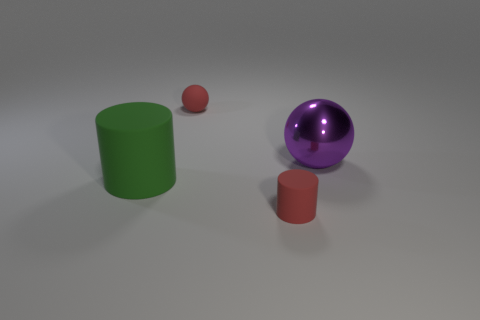Add 1 cyan metallic blocks. How many objects exist? 5 Subtract 1 cylinders. How many cylinders are left? 1 Subtract all brown balls. Subtract all gray cubes. How many balls are left? 2 Subtract all brown blocks. How many purple spheres are left? 1 Subtract all red matte balls. Subtract all gray shiny things. How many objects are left? 3 Add 2 large cylinders. How many large cylinders are left? 3 Add 1 small cylinders. How many small cylinders exist? 2 Subtract 0 green balls. How many objects are left? 4 